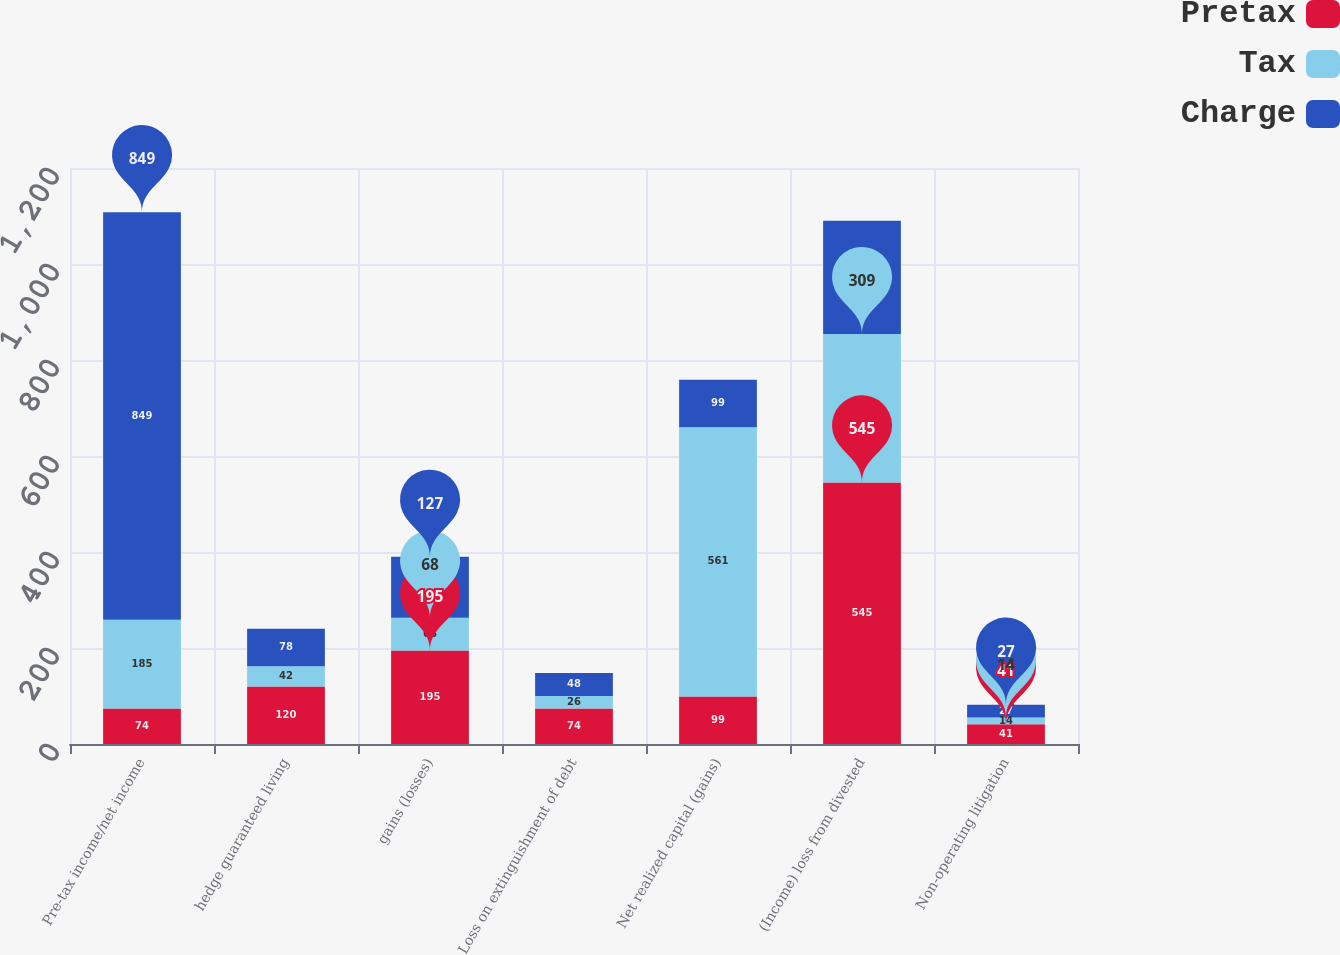Convert chart. <chart><loc_0><loc_0><loc_500><loc_500><stacked_bar_chart><ecel><fcel>Pre-tax income/net income<fcel>hedge guaranteed living<fcel>gains (losses)<fcel>Loss on extinguishment of debt<fcel>Net realized capital (gains)<fcel>(Income) loss from divested<fcel>Non-operating litigation<nl><fcel>Pretax<fcel>74<fcel>120<fcel>195<fcel>74<fcel>99<fcel>545<fcel>41<nl><fcel>Tax<fcel>185<fcel>42<fcel>68<fcel>26<fcel>561<fcel>309<fcel>14<nl><fcel>Charge<fcel>849<fcel>78<fcel>127<fcel>48<fcel>99<fcel>236<fcel>27<nl></chart> 